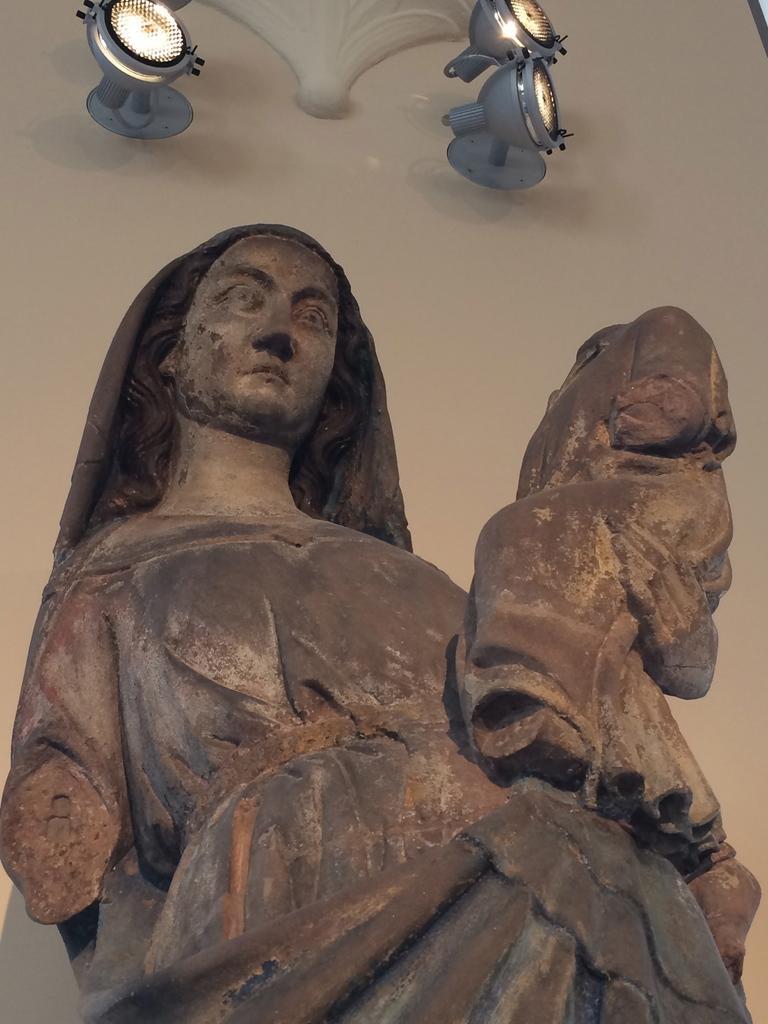In one or two sentences, can you explain what this image depicts? In this image I can see sculpture of a woman. In the background I can see few lights. 